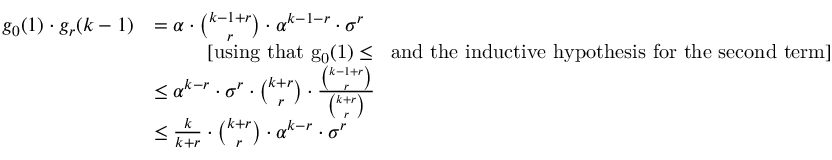Convert formula to latex. <formula><loc_0><loc_0><loc_500><loc_500>\begin{array} { r l } { g _ { 0 } ( 1 ) \cdot g _ { r } ( k - 1 ) } & { = \alpha \cdot { \binom { k - 1 + r } { r } } \cdot \alpha ^ { k - 1 - r } \cdot \sigma ^ { r } } \\ & { \quad [ u \sin g t h a t { g _ { 0 } ( 1 ) \leq \alpha } a n d t h e i n d u c t i v e h y p o t h e s i s f o r t h e s e c o n d t e r m ] } \\ & { \leq \alpha ^ { k - r } \cdot \sigma ^ { r } \cdot { \binom { k + r } { r } } \cdot \frac { { \binom { k - 1 + r } { r } } } { { \binom { k + r } { r } } } } \\ & { \leq \frac { k } { k + r } \cdot { \binom { k + r } { r } } \cdot \alpha ^ { k - r } \cdot \sigma ^ { r } } \end{array}</formula> 